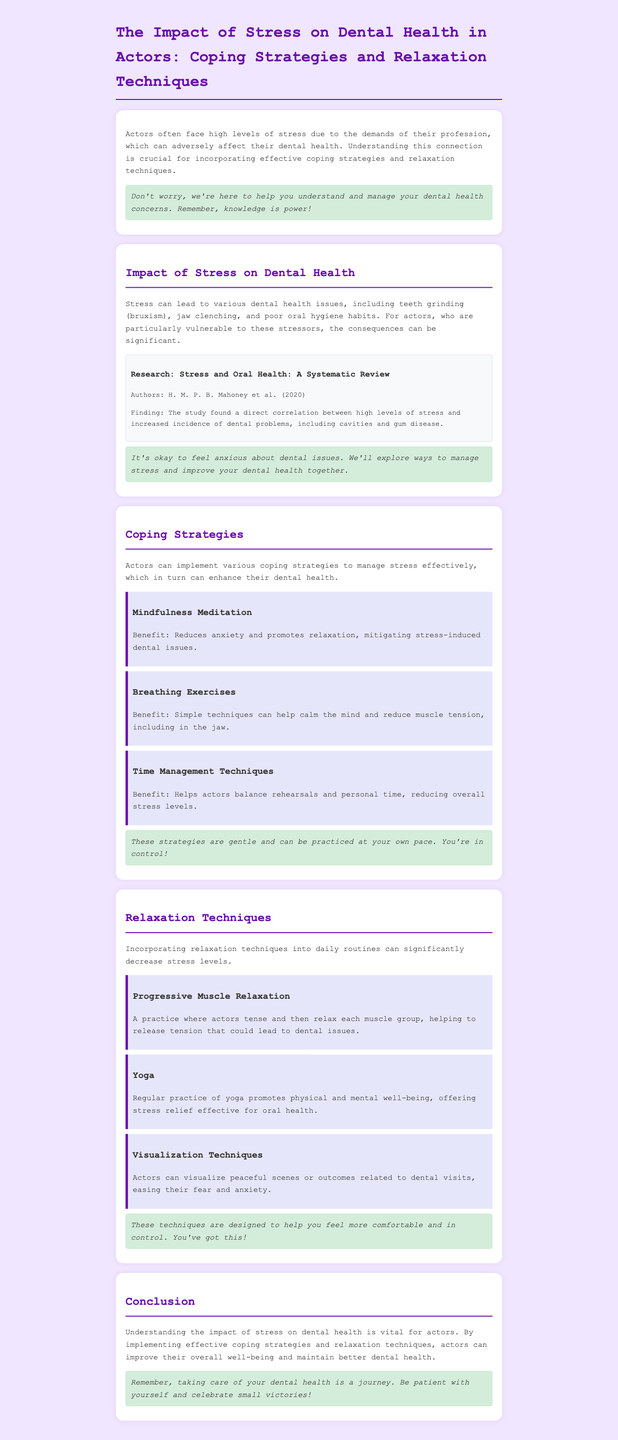What is the title of the report? The title is presented in the header of the document.
Answer: The Impact of Stress on Dental Health in Actors: Coping Strategies and Relaxation Techniques Who conducted the research mentioned in the study section? The researchers' names are provided in the study box.
Answer: H. M. P. B. Mahoney et al What year was the research published? The year of publication is specified in the study section.
Answer: 2020 Name one coping strategy mentioned in the document. The document lists several coping strategies under their respective headings.
Answer: Mindfulness Meditation What is the benefit of breathing exercises? The benefits are mentioned in the coping strategies section of the document.
Answer: Calm the mind and reduce muscle tension Which relaxation technique involves visualizing peaceful scenes? The technique is found in the relaxation techniques section.
Answer: Visualization Techniques What consequence of stress is highlighted for actors? The document indicates the consequences of stress in relation to dental health.
Answer: Poor oral hygiene habits How does yoga benefit actors in terms of stress? The benefit of yoga is described in the relaxation techniques section of the document.
Answer: Promotes physical and mental well-being How many relaxation techniques are listed in the document? The number of techniques can be counted in the relaxation techniques section.
Answer: Three 